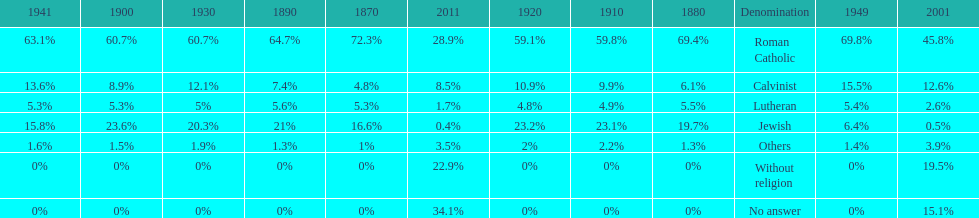Which denomination has the highest margin? Roman Catholic. 